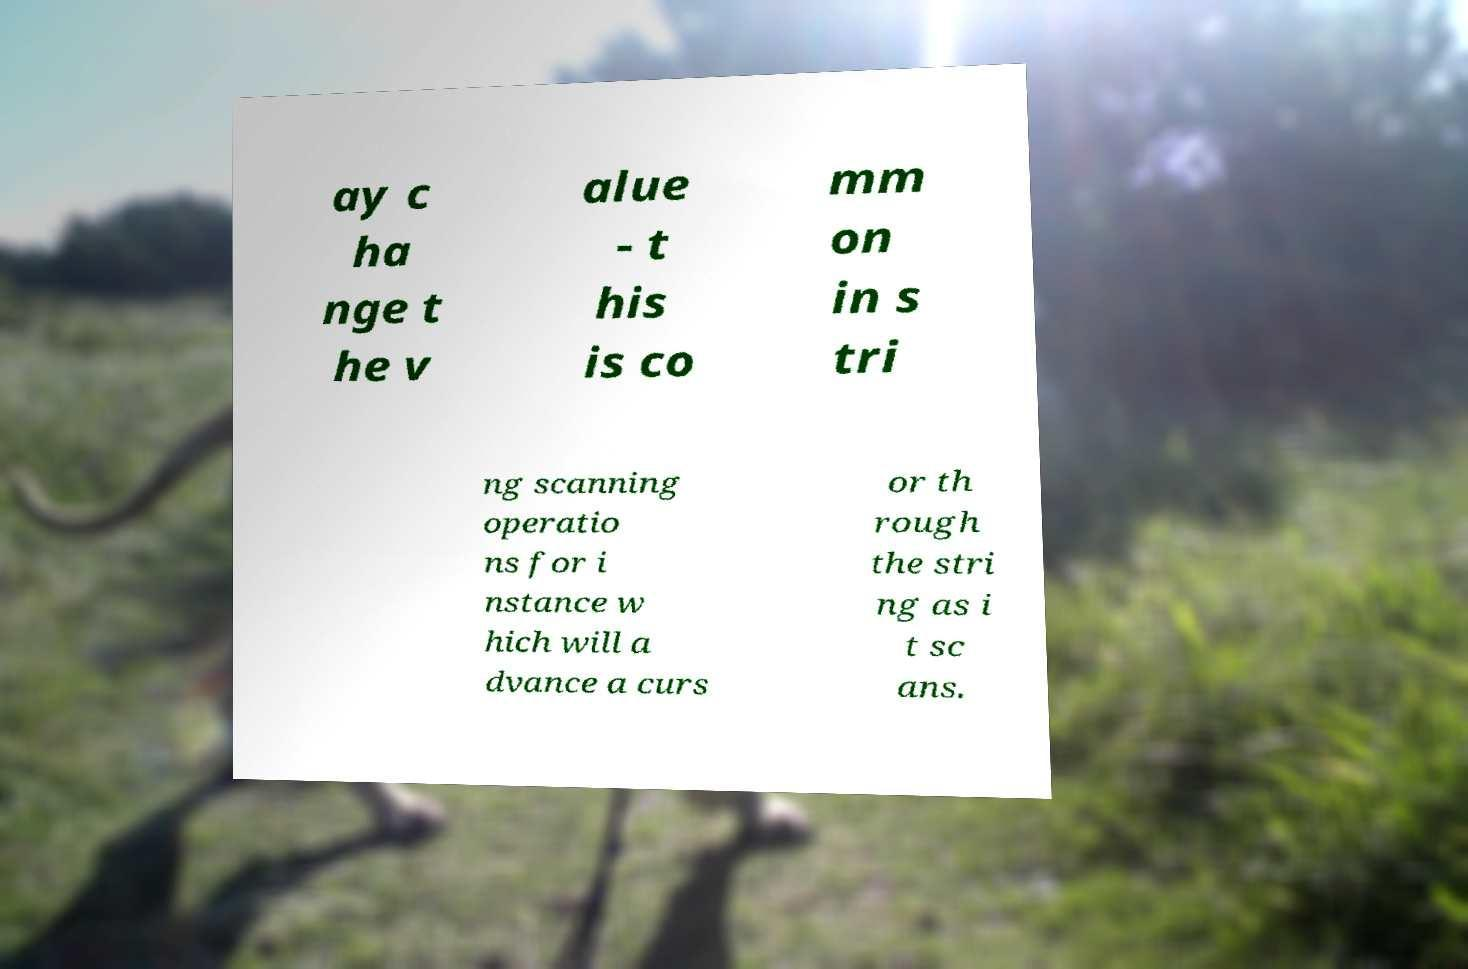For documentation purposes, I need the text within this image transcribed. Could you provide that? ay c ha nge t he v alue - t his is co mm on in s tri ng scanning operatio ns for i nstance w hich will a dvance a curs or th rough the stri ng as i t sc ans. 